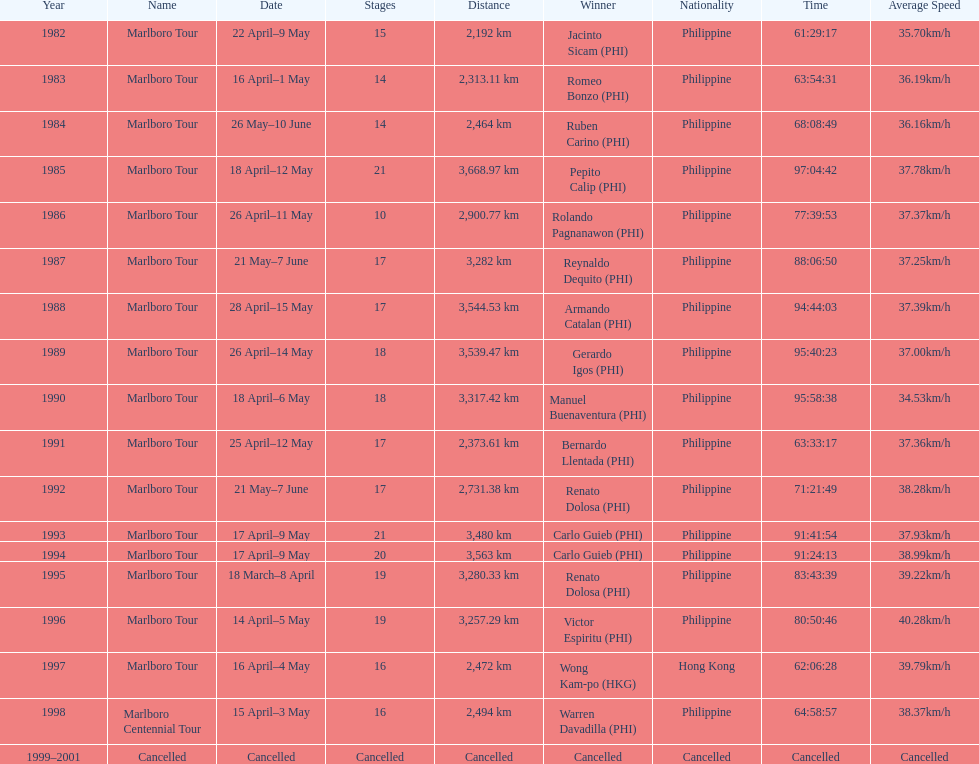Who is listed before wong kam-po? Victor Espiritu (PHI). 